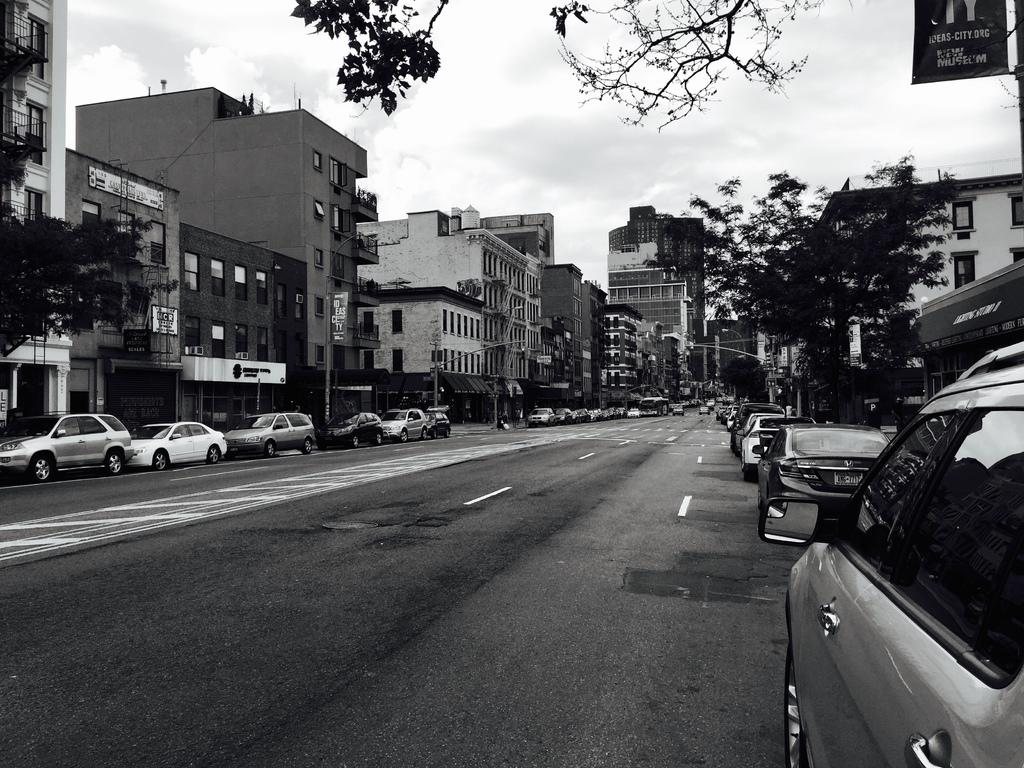What can be seen on the road in the image? There are cars parked on the road in the image. What is visible behind the parked cars? There are trees and buildings behind the parked cars. What is the condition of the sky in the image? The sky is clear and visible in the image. How is the image presented in terms of color? The image is in black and white color. How many friends are sitting on the baby's lap in the image? There are no friends or babies present in the image; it features parked cars, trees, buildings, and a clear sky. 